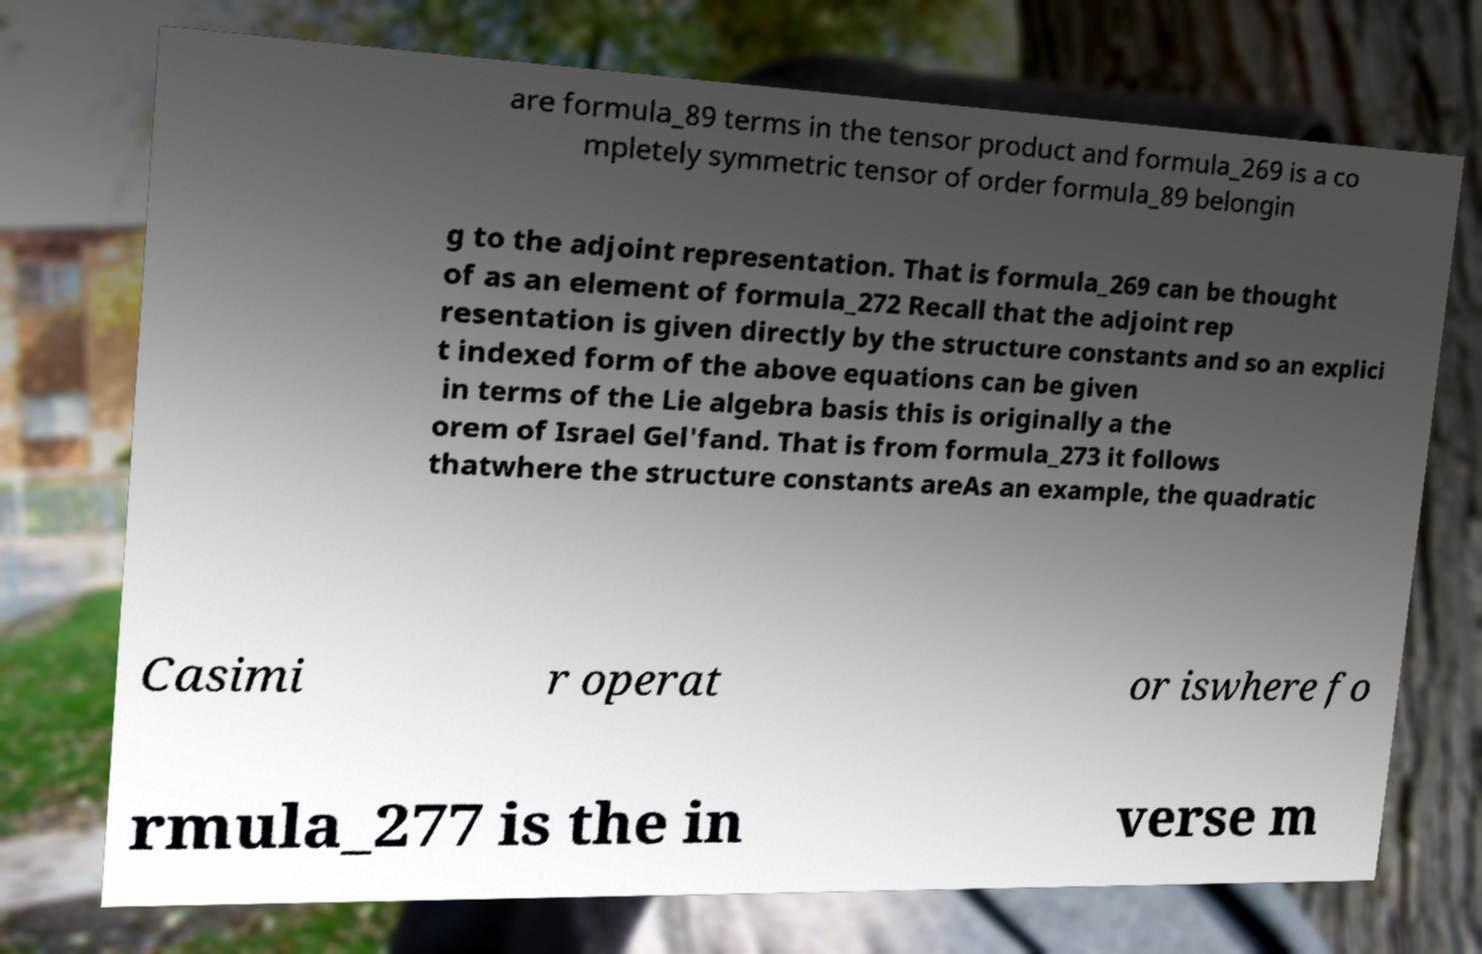Could you assist in decoding the text presented in this image and type it out clearly? are formula_89 terms in the tensor product and formula_269 is a co mpletely symmetric tensor of order formula_89 belongin g to the adjoint representation. That is formula_269 can be thought of as an element of formula_272 Recall that the adjoint rep resentation is given directly by the structure constants and so an explici t indexed form of the above equations can be given in terms of the Lie algebra basis this is originally a the orem of Israel Gel'fand. That is from formula_273 it follows thatwhere the structure constants areAs an example, the quadratic Casimi r operat or iswhere fo rmula_277 is the in verse m 